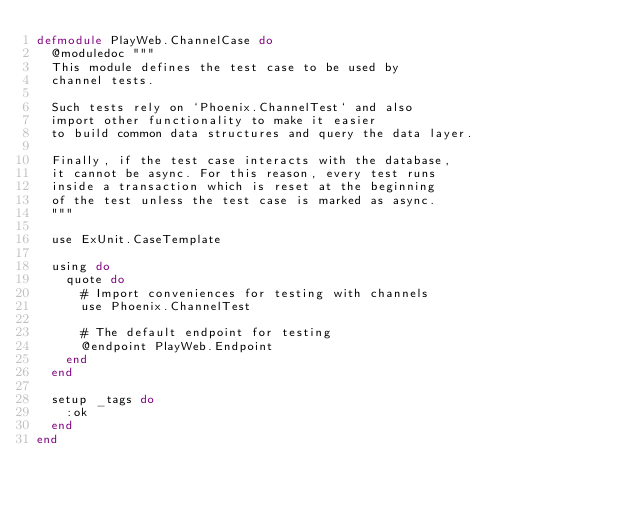<code> <loc_0><loc_0><loc_500><loc_500><_Elixir_>defmodule PlayWeb.ChannelCase do
  @moduledoc """
  This module defines the test case to be used by
  channel tests.

  Such tests rely on `Phoenix.ChannelTest` and also
  import other functionality to make it easier
  to build common data structures and query the data layer.

  Finally, if the test case interacts with the database,
  it cannot be async. For this reason, every test runs
  inside a transaction which is reset at the beginning
  of the test unless the test case is marked as async.
  """

  use ExUnit.CaseTemplate

  using do
    quote do
      # Import conveniences for testing with channels
      use Phoenix.ChannelTest

      # The default endpoint for testing
      @endpoint PlayWeb.Endpoint
    end
  end

  setup _tags do
    :ok
  end
end
</code> 